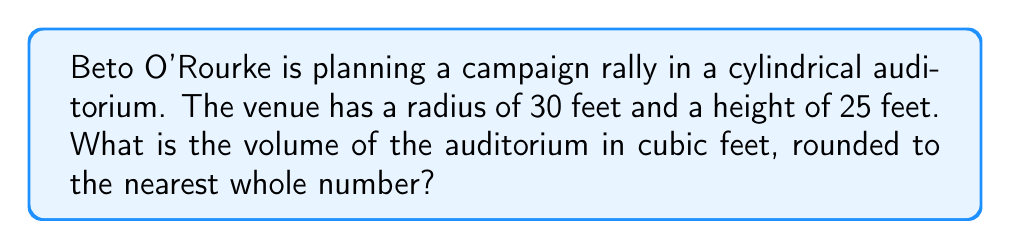Show me your answer to this math problem. To solve this problem, we'll use the formula for the volume of a cylinder:

$$V = \pi r^2 h$$

Where:
$V$ = volume
$r$ = radius
$h$ = height

Given:
$r = 30$ feet
$h = 25$ feet

Let's substitute these values into the formula:

$$V = \pi (30 \text{ ft})^2 (25 \text{ ft})$$

Simplify:
$$V = \pi (900 \text{ ft}^2) (25 \text{ ft})$$
$$V = 22,500\pi \text{ ft}^3$$

Using $\pi \approx 3.14159$:

$$V \approx 22,500 (3.14159) \text{ ft}^3$$
$$V \approx 70,685.775 \text{ ft}^3$$

Rounding to the nearest whole number:

$$V \approx 70,686 \text{ ft}^3$$

This large volume ensures that many supporters can attend Beto O'Rourke's rally in the cylindrical auditorium.
Answer: 70,686 ft³ 